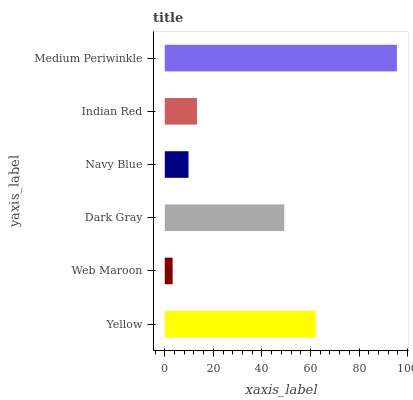Is Web Maroon the minimum?
Answer yes or no. Yes. Is Medium Periwinkle the maximum?
Answer yes or no. Yes. Is Dark Gray the minimum?
Answer yes or no. No. Is Dark Gray the maximum?
Answer yes or no. No. Is Dark Gray greater than Web Maroon?
Answer yes or no. Yes. Is Web Maroon less than Dark Gray?
Answer yes or no. Yes. Is Web Maroon greater than Dark Gray?
Answer yes or no. No. Is Dark Gray less than Web Maroon?
Answer yes or no. No. Is Dark Gray the high median?
Answer yes or no. Yes. Is Indian Red the low median?
Answer yes or no. Yes. Is Navy Blue the high median?
Answer yes or no. No. Is Navy Blue the low median?
Answer yes or no. No. 